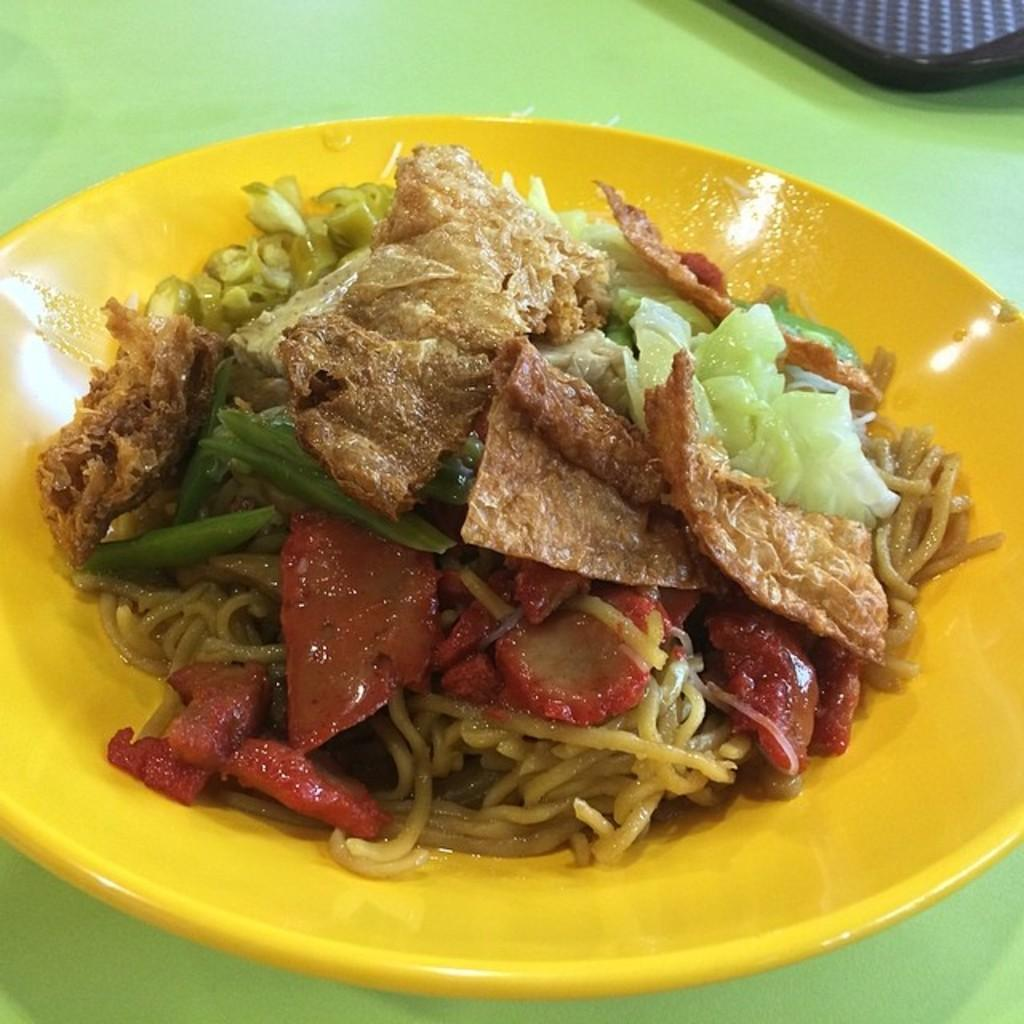What is the main object in the image? There is an object in the image, but its specific details are not mentioned in the facts. What can be found on the plate in the image? There is a plate with food items in the image. What is the color or material of the surface on which the plate and object are placed? The plate and the object are placed on a green surface. What is the trade limit for the basin in the image? There is no mention of a trade limit or a basin in the image, so this question cannot be answered definitively. 